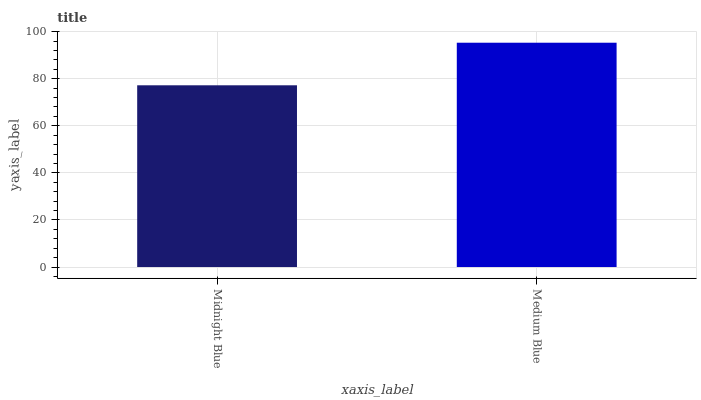Is Midnight Blue the minimum?
Answer yes or no. Yes. Is Medium Blue the maximum?
Answer yes or no. Yes. Is Medium Blue the minimum?
Answer yes or no. No. Is Medium Blue greater than Midnight Blue?
Answer yes or no. Yes. Is Midnight Blue less than Medium Blue?
Answer yes or no. Yes. Is Midnight Blue greater than Medium Blue?
Answer yes or no. No. Is Medium Blue less than Midnight Blue?
Answer yes or no. No. Is Medium Blue the high median?
Answer yes or no. Yes. Is Midnight Blue the low median?
Answer yes or no. Yes. Is Midnight Blue the high median?
Answer yes or no. No. Is Medium Blue the low median?
Answer yes or no. No. 